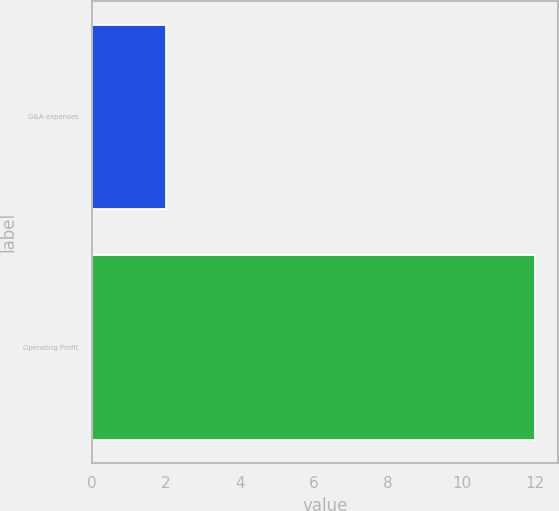Convert chart to OTSL. <chart><loc_0><loc_0><loc_500><loc_500><bar_chart><fcel>G&A expenses<fcel>Operating Profit<nl><fcel>2<fcel>12<nl></chart> 